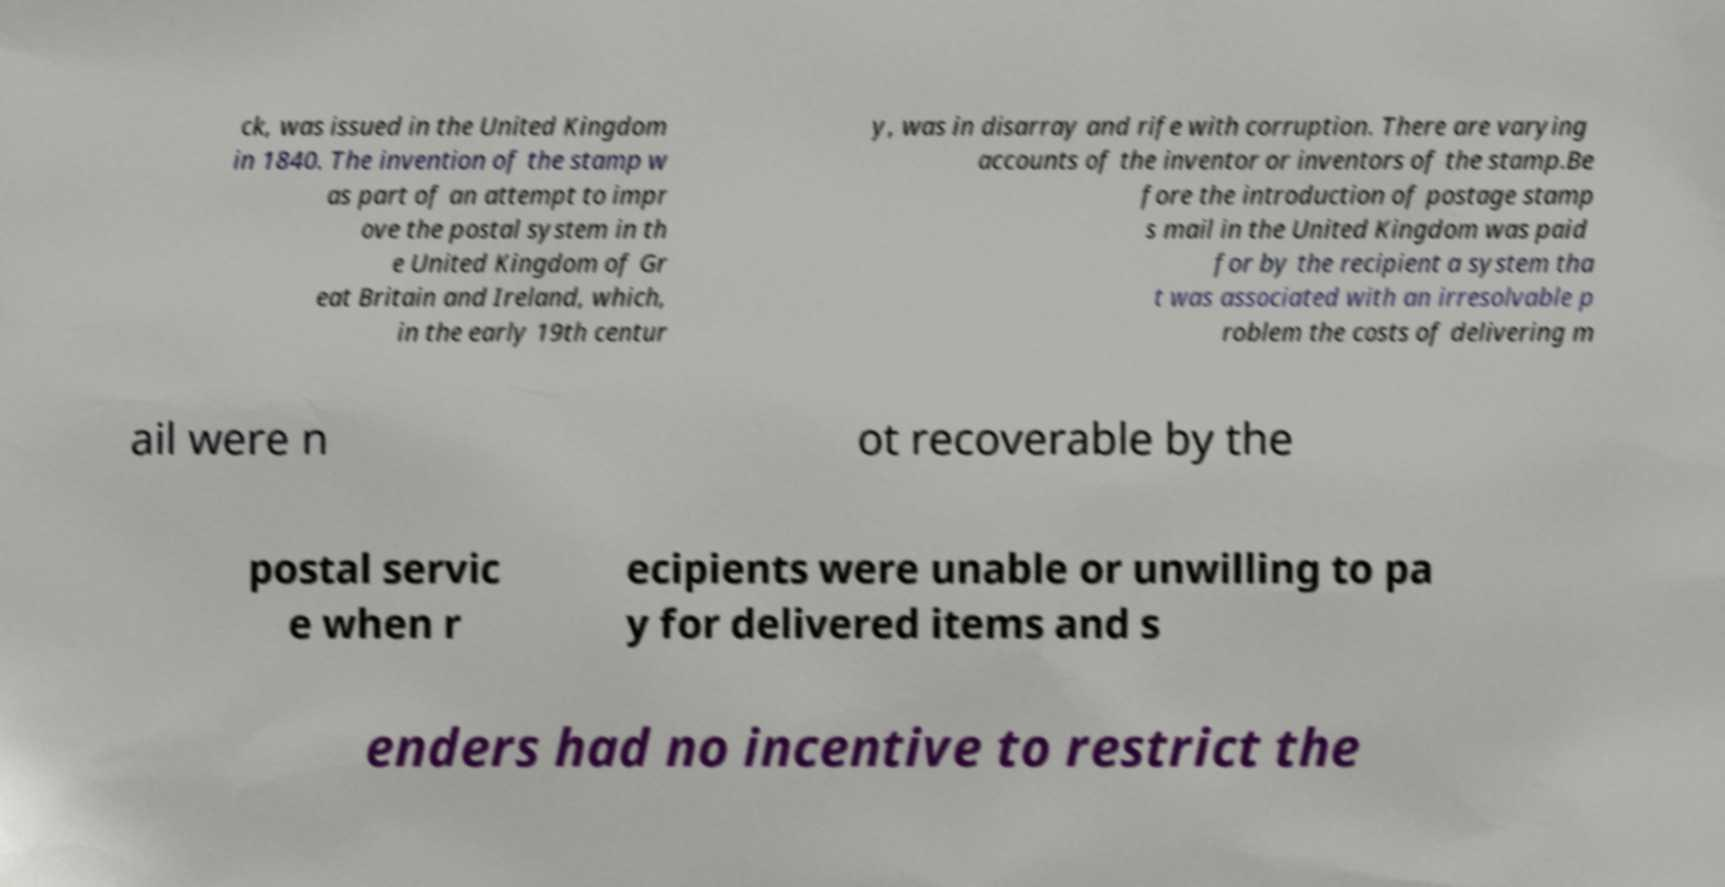Please identify and transcribe the text found in this image. ck, was issued in the United Kingdom in 1840. The invention of the stamp w as part of an attempt to impr ove the postal system in th e United Kingdom of Gr eat Britain and Ireland, which, in the early 19th centur y, was in disarray and rife with corruption. There are varying accounts of the inventor or inventors of the stamp.Be fore the introduction of postage stamp s mail in the United Kingdom was paid for by the recipient a system tha t was associated with an irresolvable p roblem the costs of delivering m ail were n ot recoverable by the postal servic e when r ecipients were unable or unwilling to pa y for delivered items and s enders had no incentive to restrict the 